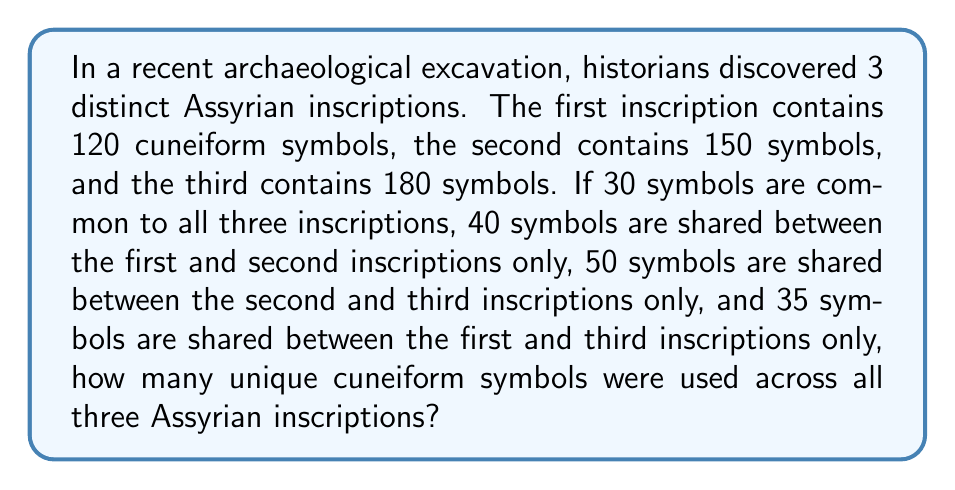Can you solve this math problem? Let's approach this step-by-step using the principle of inclusion-exclusion:

1) Let's define sets:
   A = symbols in the first inscription
   B = symbols in the second inscription
   C = symbols in the third inscription

2) We're given:
   $|A| = 120$, $|B| = 150$, $|C| = 180$
   $|A \cap B \cap C| = 30$
   $|A \cap B| - |A \cap B \cap C| = 40$
   $|B \cap C| - |A \cap B \cap C| = 50$
   $|A \cap C| - |A \cap B \cap C| = 35$

3) We need to find $|A \cup B \cup C|$

4) The inclusion-exclusion principle states:
   $$|A \cup B \cup C| = |A| + |B| + |C| - |A \cap B| - |B \cap C| - |A \cap C| + |A \cap B \cap C|$$

5) We know $|A \cap B \cap C| = 30$

6) We can calculate:
   $|A \cap B| = 40 + 30 = 70$
   $|B \cap C| = 50 + 30 = 80$
   $|A \cap C| = 35 + 30 = 65$

7) Now we can substitute into the formula:
   $$|A \cup B \cup C| = 120 + 150 + 180 - 70 - 80 - 65 + 30 = 265$$

Therefore, there are 265 unique cuneiform symbols used across all three Assyrian inscriptions.
Answer: 265 